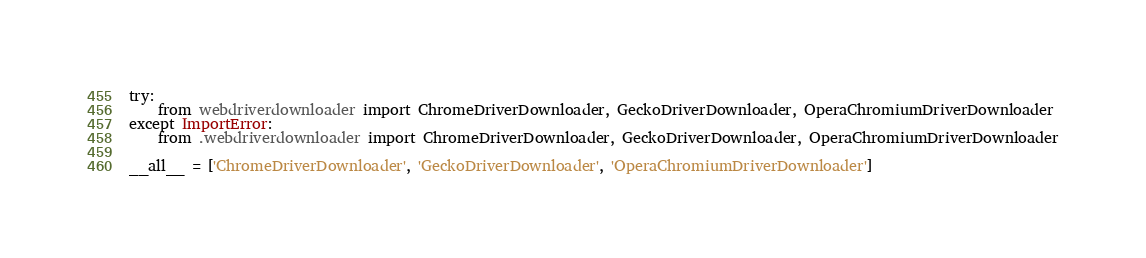<code> <loc_0><loc_0><loc_500><loc_500><_Python_>try:
    from webdriverdownloader import ChromeDriverDownloader, GeckoDriverDownloader, OperaChromiumDriverDownloader
except ImportError:
    from .webdriverdownloader import ChromeDriverDownloader, GeckoDriverDownloader, OperaChromiumDriverDownloader

__all__ = ['ChromeDriverDownloader', 'GeckoDriverDownloader', 'OperaChromiumDriverDownloader']
</code> 